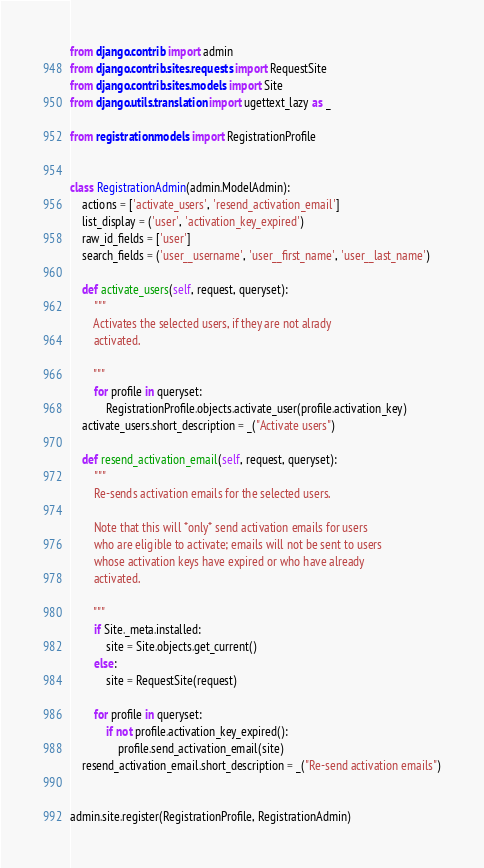<code> <loc_0><loc_0><loc_500><loc_500><_Python_>from django.contrib import admin
from django.contrib.sites.requests import RequestSite
from django.contrib.sites.models import Site
from django.utils.translation import ugettext_lazy as _

from registration.models import RegistrationProfile


class RegistrationAdmin(admin.ModelAdmin):
    actions = ['activate_users', 'resend_activation_email']
    list_display = ('user', 'activation_key_expired')
    raw_id_fields = ['user']
    search_fields = ('user__username', 'user__first_name', 'user__last_name')

    def activate_users(self, request, queryset):
        """
        Activates the selected users, if they are not alrady
        activated.
        
        """
        for profile in queryset:
            RegistrationProfile.objects.activate_user(profile.activation_key)
    activate_users.short_description = _("Activate users")

    def resend_activation_email(self, request, queryset):
        """
        Re-sends activation emails for the selected users.

        Note that this will *only* send activation emails for users
        who are eligible to activate; emails will not be sent to users
        whose activation keys have expired or who have already
        activated.
        
        """
        if Site._meta.installed:
            site = Site.objects.get_current()
        else:
            site = RequestSite(request)

        for profile in queryset:
            if not profile.activation_key_expired():
                profile.send_activation_email(site)
    resend_activation_email.short_description = _("Re-send activation emails")


admin.site.register(RegistrationProfile, RegistrationAdmin)
</code> 